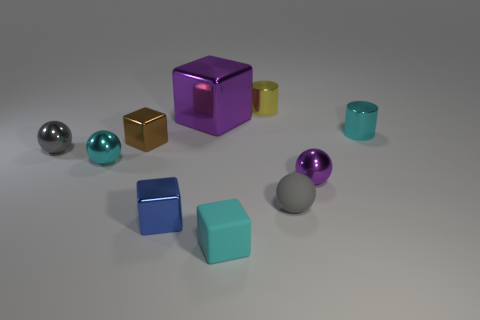Is there any pattern or theme to the arrangement of objects? The objects are thoughtfully arranged by size and color, suggesting a deliberate presentation intended to display contrast and variation. The arrangement seems to mirror the diversity in shapes, from the perfect symmetry of the spheres to the defined angles of the cubes, as well as the range in colors, from metallic to matte finishes. 